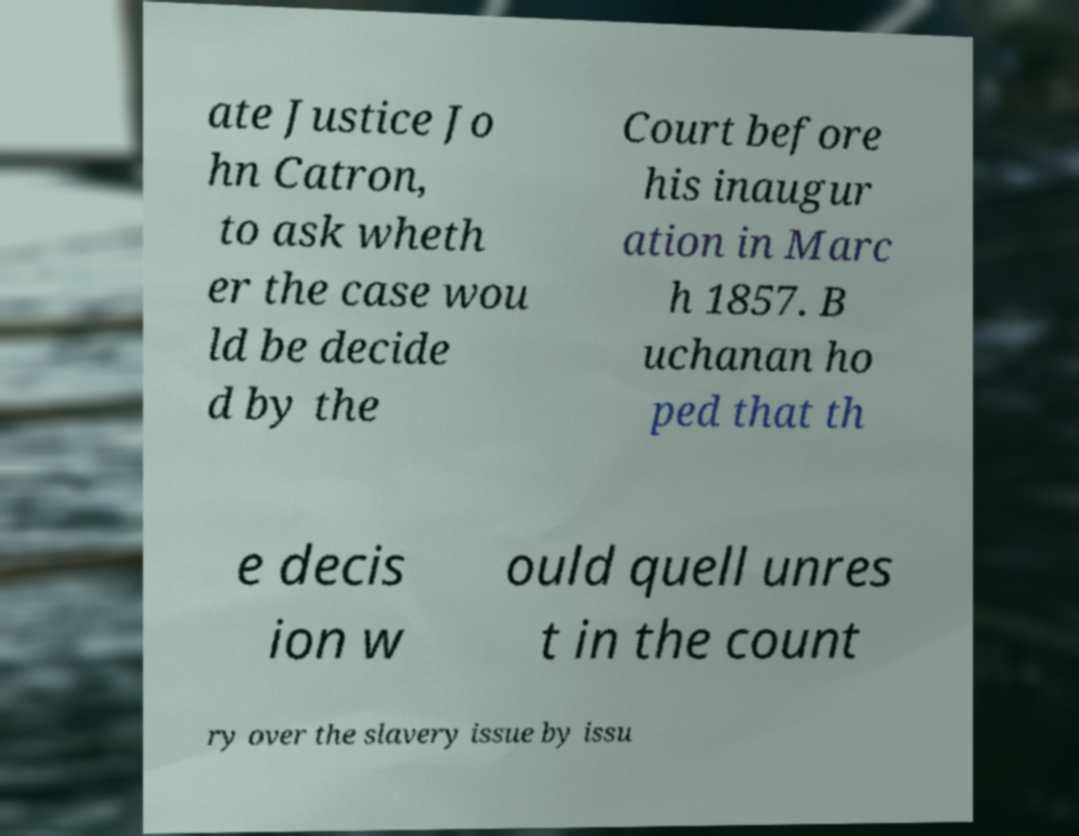Please identify and transcribe the text found in this image. ate Justice Jo hn Catron, to ask wheth er the case wou ld be decide d by the Court before his inaugur ation in Marc h 1857. B uchanan ho ped that th e decis ion w ould quell unres t in the count ry over the slavery issue by issu 